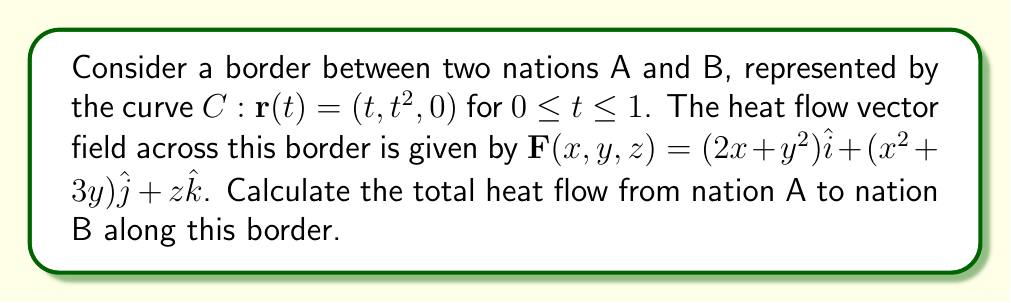Help me with this question. To solve this problem, we need to evaluate the line integral of the vector field $\mathbf{F}$ along the curve $C$. The steps are as follows:

1) The line integral is given by:
   $$\int_C \mathbf{F} \cdot d\mathbf{r} = \int_a^b \mathbf{F}(\mathbf{r}(t)) \cdot \mathbf{r}'(t) dt$$

2) We have $\mathbf{r}(t) = (t, t^2, 0)$ for $0 \leq t \leq 1$, so $\mathbf{r}'(t) = (1, 2t, 0)$

3) Evaluate $\mathbf{F}(\mathbf{r}(t))$:
   $$\mathbf{F}(\mathbf{r}(t)) = (2t + t^4)\hat{i} + (t^2 + 3t^2)\hat{j} + 0\hat{k} = (2t + t^4)\hat{i} + (4t^2)\hat{j}$$

4) Calculate $\mathbf{F}(\mathbf{r}(t)) \cdot \mathbf{r}'(t)$:
   $$(2t + t^4, 4t^2, 0) \cdot (1, 2t, 0) = (2t + t^4) + (8t^3) = 2t + 8t^3 + t^4$$

5) Now we can set up the integral:
   $$\int_0^1 (2t + 8t^3 + t^4) dt$$

6) Integrate:
   $$\left[ t^2 + 2t^4 + \frac{1}{5}t^5 \right]_0^1 = (1 + 2 + \frac{1}{5}) - (0) = \frac{16}{5}$$

Therefore, the total heat flow from nation A to nation B along this border is $\frac{16}{5}$ units.
Answer: $\frac{16}{5}$ units 